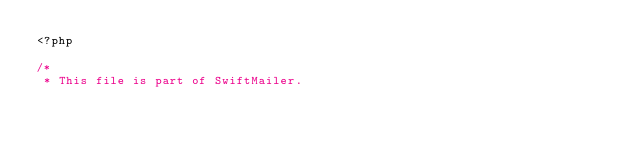<code> <loc_0><loc_0><loc_500><loc_500><_PHP_><?php

/*
 * This file is part of SwiftMailer.</code> 